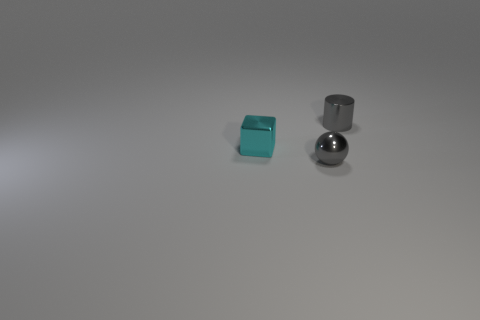What number of spheres are metal objects or tiny gray metal things?
Offer a terse response. 1. What shape is the gray object that is on the left side of the tiny gray shiny thing that is behind the tiny cyan metallic thing?
Give a very brief answer. Sphere. How big is the gray object that is left of the small gray thing behind the tiny gray metal object that is left of the small gray shiny cylinder?
Give a very brief answer. Small. Does the cylinder have the same size as the cyan object?
Your response must be concise. Yes. What number of things are cyan objects or blue shiny cylinders?
Keep it short and to the point. 1. How big is the gray metal ball in front of the tiny shiny thing to the right of the metal sphere?
Provide a succinct answer. Small. What size is the gray ball?
Give a very brief answer. Small. There is a tiny object that is behind the sphere and right of the cyan block; what shape is it?
Give a very brief answer. Cylinder. How many things are things that are behind the cyan block or small objects that are on the right side of the sphere?
Give a very brief answer. 1. The cyan object is what shape?
Offer a very short reply. Cube. 